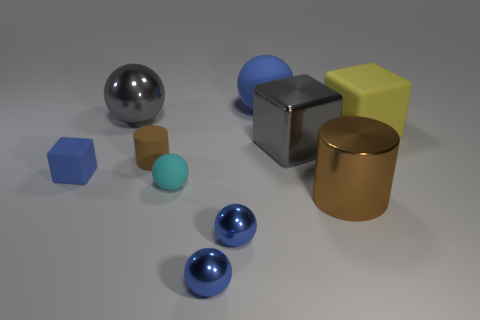Do the large cylinder and the tiny cylinder have the same color?
Provide a succinct answer. Yes. There is a ball that is right of the gray metallic sphere and behind the cyan ball; what is its color?
Ensure brevity in your answer.  Blue. Is the size of the blue rubber thing behind the yellow block the same as the cyan object?
Keep it short and to the point. No. Are there any other things that have the same shape as the tiny cyan rubber thing?
Offer a very short reply. Yes. Is the yellow object made of the same material as the cylinder in front of the brown rubber object?
Make the answer very short. No. How many cyan things are either small blocks or big rubber spheres?
Provide a short and direct response. 0. Are there any large rubber things?
Ensure brevity in your answer.  Yes. There is a matte block that is behind the blue matte thing on the left side of the small brown rubber thing; is there a matte cylinder behind it?
Ensure brevity in your answer.  No. Is there any other thing that has the same size as the gray metallic sphere?
Ensure brevity in your answer.  Yes. There is a big brown thing; is its shape the same as the big gray shiny object on the right side of the matte cylinder?
Make the answer very short. No. 